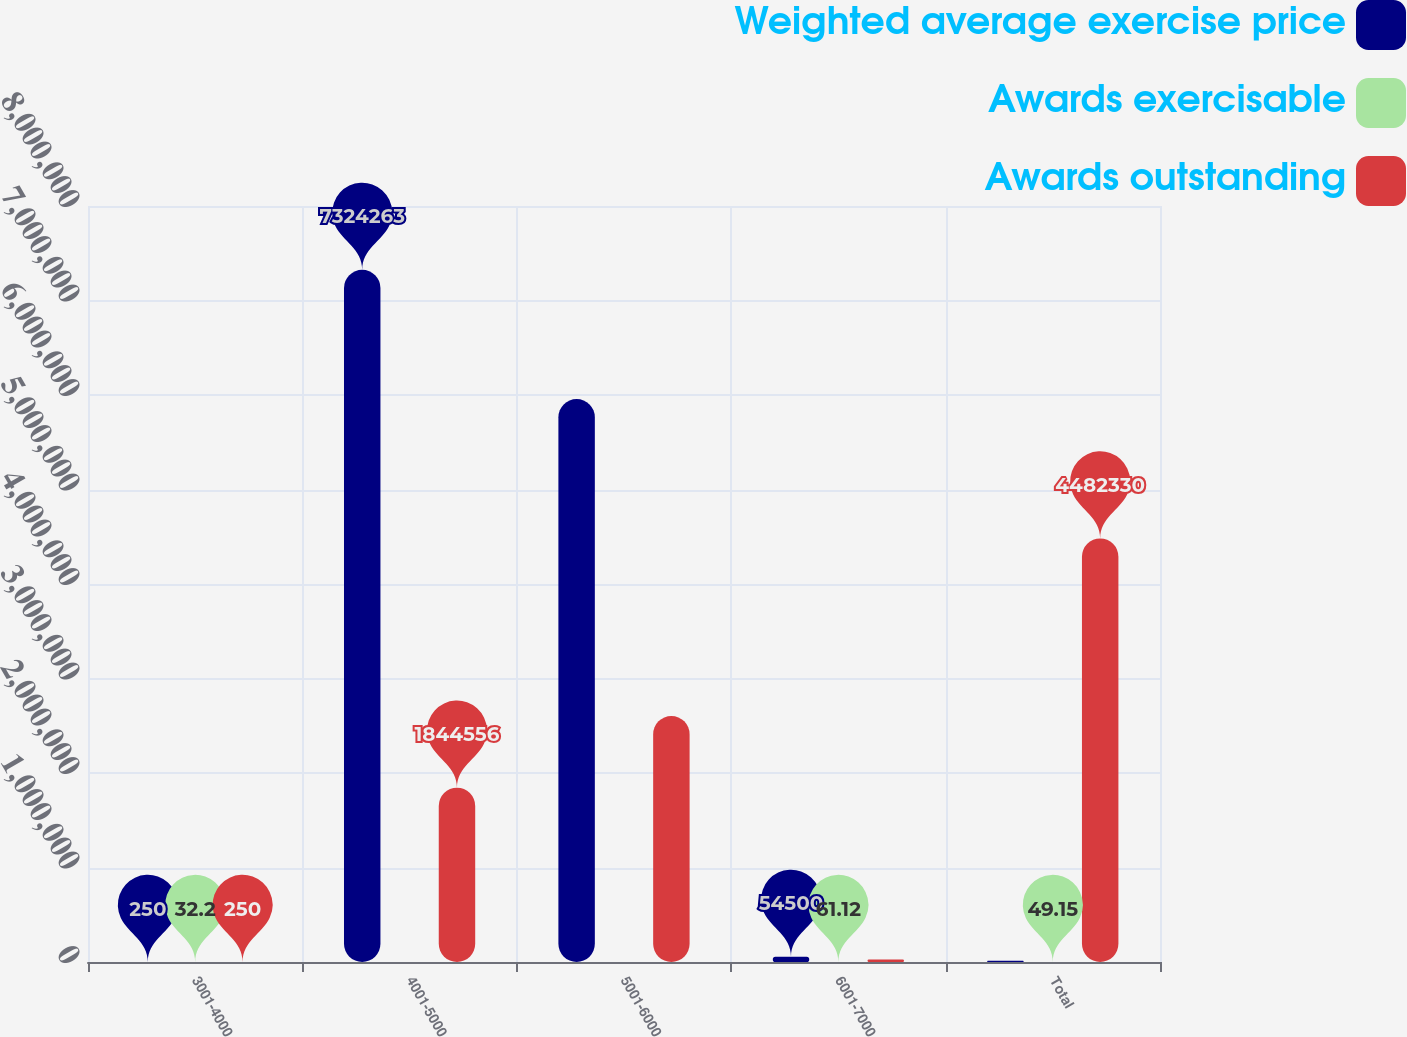<chart> <loc_0><loc_0><loc_500><loc_500><stacked_bar_chart><ecel><fcel>3001-4000<fcel>4001-5000<fcel>5001-6000<fcel>6001-7000<fcel>Total<nl><fcel>Weighted average exercise price<fcel>250<fcel>7.32426e+06<fcel>5.95718e+06<fcel>54500<fcel>12936.5<nl><fcel>Awards exercisable<fcel>32.2<fcel>46.52<fcel>52.85<fcel>61.12<fcel>49.15<nl><fcel>Awards outstanding<fcel>250<fcel>1.84456e+06<fcel>2.60309e+06<fcel>25623<fcel>4.48233e+06<nl></chart> 